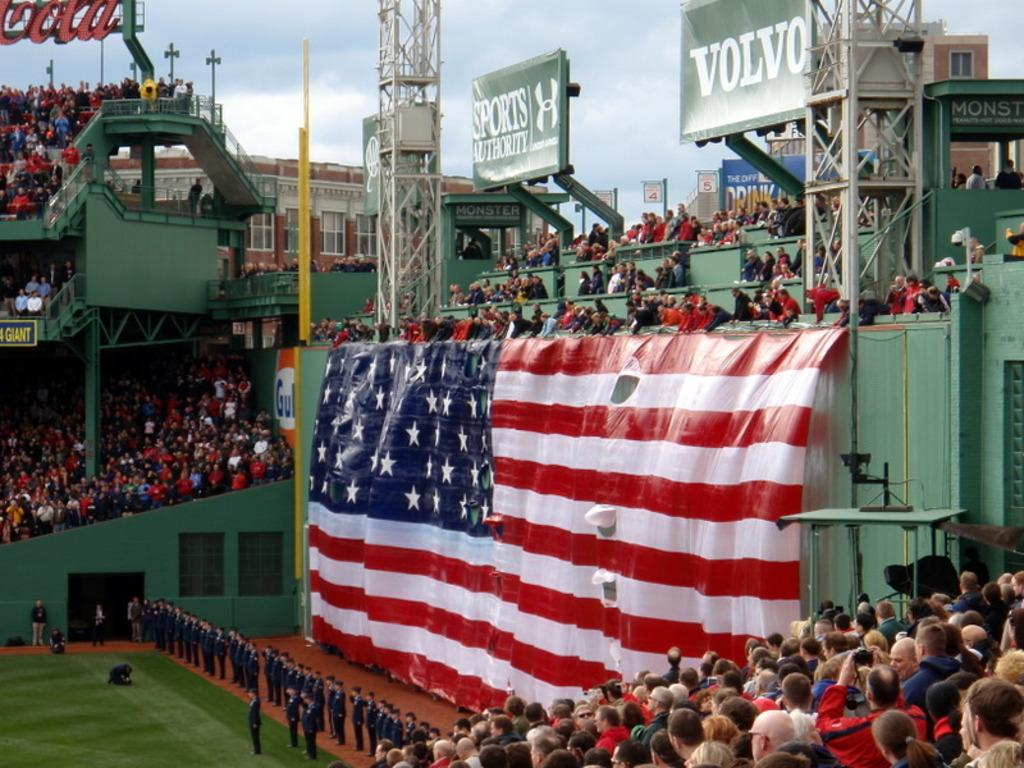<image>
Present a compact description of the photo's key features. green colored stadium full of people with large american flag and a volvo sign above it 